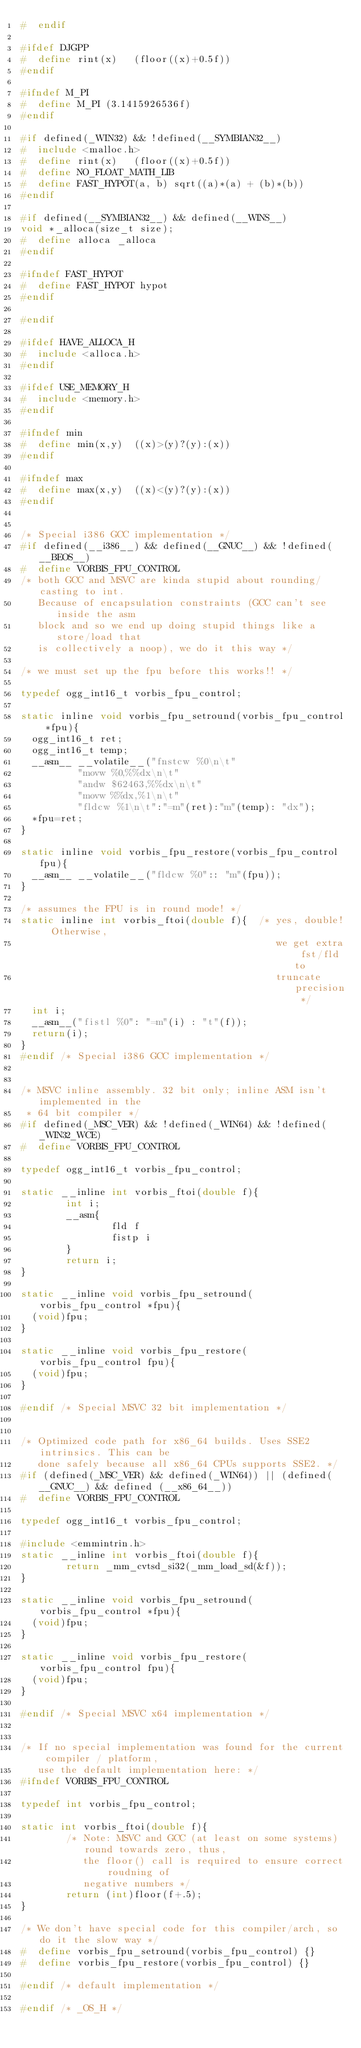Convert code to text. <code><loc_0><loc_0><loc_500><loc_500><_C_>#  endif

#ifdef DJGPP
#  define rint(x)   (floor((x)+0.5f))
#endif

#ifndef M_PI
#  define M_PI (3.1415926536f)
#endif

#if defined(_WIN32) && !defined(__SYMBIAN32__)
#  include <malloc.h>
#  define rint(x)   (floor((x)+0.5f))
#  define NO_FLOAT_MATH_LIB
#  define FAST_HYPOT(a, b) sqrt((a)*(a) + (b)*(b))
#endif

#if defined(__SYMBIAN32__) && defined(__WINS__)
void *_alloca(size_t size);
#  define alloca _alloca
#endif

#ifndef FAST_HYPOT
#  define FAST_HYPOT hypot
#endif

#endif

#ifdef HAVE_ALLOCA_H
#  include <alloca.h>
#endif

#ifdef USE_MEMORY_H
#  include <memory.h>
#endif

#ifndef min
#  define min(x,y)  ((x)>(y)?(y):(x))
#endif

#ifndef max
#  define max(x,y)  ((x)<(y)?(y):(x))
#endif


/* Special i386 GCC implementation */
#if defined(__i386__) && defined(__GNUC__) && !defined(__BEOS__)
#  define VORBIS_FPU_CONTROL
/* both GCC and MSVC are kinda stupid about rounding/casting to int.
   Because of encapsulation constraints (GCC can't see inside the asm
   block and so we end up doing stupid things like a store/load that
   is collectively a noop), we do it this way */

/* we must set up the fpu before this works!! */

typedef ogg_int16_t vorbis_fpu_control;

static inline void vorbis_fpu_setround(vorbis_fpu_control *fpu){
  ogg_int16_t ret;
  ogg_int16_t temp;
  __asm__ __volatile__("fnstcw %0\n\t"
          "movw %0,%%dx\n\t"
          "andw $62463,%%dx\n\t"
          "movw %%dx,%1\n\t"
          "fldcw %1\n\t":"=m"(ret):"m"(temp): "dx");
  *fpu=ret;
}

static inline void vorbis_fpu_restore(vorbis_fpu_control fpu){
  __asm__ __volatile__("fldcw %0":: "m"(fpu));
}

/* assumes the FPU is in round mode! */
static inline int vorbis_ftoi(double f){  /* yes, double!  Otherwise,
                                             we get extra fst/fld to
                                             truncate precision */
  int i;
  __asm__("fistl %0": "=m"(i) : "t"(f));
  return(i);
}
#endif /* Special i386 GCC implementation */


/* MSVC inline assembly. 32 bit only; inline ASM isn't implemented in the
 * 64 bit compiler */
#if defined(_MSC_VER) && !defined(_WIN64) && !defined(_WIN32_WCE)
#  define VORBIS_FPU_CONTROL

typedef ogg_int16_t vorbis_fpu_control;

static __inline int vorbis_ftoi(double f){
        int i;
        __asm{
                fld f
                fistp i
        }
        return i;
}

static __inline void vorbis_fpu_setround(vorbis_fpu_control *fpu){
  (void)fpu;
}

static __inline void vorbis_fpu_restore(vorbis_fpu_control fpu){
  (void)fpu;
}

#endif /* Special MSVC 32 bit implementation */


/* Optimized code path for x86_64 builds. Uses SSE2 intrinsics. This can be
   done safely because all x86_64 CPUs supports SSE2. */
#if (defined(_MSC_VER) && defined(_WIN64)) || (defined(__GNUC__) && defined (__x86_64__))
#  define VORBIS_FPU_CONTROL

typedef ogg_int16_t vorbis_fpu_control;

#include <emmintrin.h>
static __inline int vorbis_ftoi(double f){
        return _mm_cvtsd_si32(_mm_load_sd(&f));
}

static __inline void vorbis_fpu_setround(vorbis_fpu_control *fpu){
  (void)fpu;
}

static __inline void vorbis_fpu_restore(vorbis_fpu_control fpu){
  (void)fpu;
}

#endif /* Special MSVC x64 implementation */


/* If no special implementation was found for the current compiler / platform,
   use the default implementation here: */
#ifndef VORBIS_FPU_CONTROL

typedef int vorbis_fpu_control;

static int vorbis_ftoi(double f){
        /* Note: MSVC and GCC (at least on some systems) round towards zero, thus,
           the floor() call is required to ensure correct roudning of
           negative numbers */
        return (int)floor(f+.5);
}

/* We don't have special code for this compiler/arch, so do it the slow way */
#  define vorbis_fpu_setround(vorbis_fpu_control) {}
#  define vorbis_fpu_restore(vorbis_fpu_control) {}

#endif /* default implementation */

#endif /* _OS_H */
</code> 